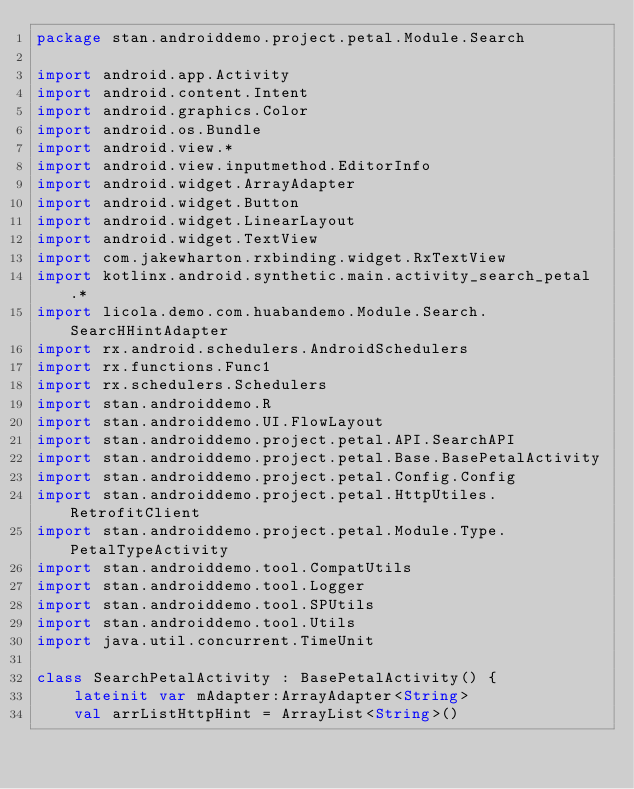Convert code to text. <code><loc_0><loc_0><loc_500><loc_500><_Kotlin_>package stan.androiddemo.project.petal.Module.Search

import android.app.Activity
import android.content.Intent
import android.graphics.Color
import android.os.Bundle
import android.view.*
import android.view.inputmethod.EditorInfo
import android.widget.ArrayAdapter
import android.widget.Button
import android.widget.LinearLayout
import android.widget.TextView
import com.jakewharton.rxbinding.widget.RxTextView
import kotlinx.android.synthetic.main.activity_search_petal.*
import licola.demo.com.huabandemo.Module.Search.SearcHHintAdapter
import rx.android.schedulers.AndroidSchedulers
import rx.functions.Func1
import rx.schedulers.Schedulers
import stan.androiddemo.R
import stan.androiddemo.UI.FlowLayout
import stan.androiddemo.project.petal.API.SearchAPI
import stan.androiddemo.project.petal.Base.BasePetalActivity
import stan.androiddemo.project.petal.Config.Config
import stan.androiddemo.project.petal.HttpUtiles.RetrofitClient
import stan.androiddemo.project.petal.Module.Type.PetalTypeActivity
import stan.androiddemo.tool.CompatUtils
import stan.androiddemo.tool.Logger
import stan.androiddemo.tool.SPUtils
import stan.androiddemo.tool.Utils
import java.util.concurrent.TimeUnit

class SearchPetalActivity : BasePetalActivity() {
    lateinit var mAdapter:ArrayAdapter<String>
    val arrListHttpHint = ArrayList<String>()</code> 